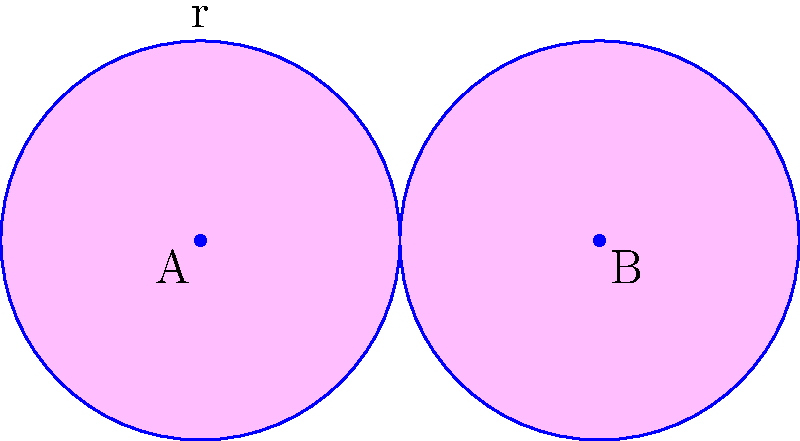In the diagram above, two circles with radius $r=1$ unit are centered at points A and B, which are 2 units apart. The overlapping region forms a heart shape, symbolic of the deep connection between two characters in a girls' love series. Calculate the area of this heart-shaped region. To find the area of the heart-shaped region, we'll follow these steps:

1) The total area of the heart shape is equal to the area of two circles minus the area of their intersection.

2) Area of one circle: $A_c = \pi r^2 = \pi (1)^2 = \pi$

3) Area of two circles: $2\pi$

4) To find the area of intersection, we need to calculate the area of the lens-shaped region formed by the overlapping circles.

5) The area of this lens can be calculated using the formula:
   $A_{\text{lens}} = 2r^2 \arccos(\frac{d}{2r}) - d\sqrt{r^2 - (\frac{d}{2})^2}$
   where $d$ is the distance between the centers and $r$ is the radius.

6) Here, $d = 2$ and $r = 1$, so:
   $A_{\text{lens}} = 2(1)^2 \arccos(\frac{2}{2(1)}) - 2\sqrt{1^2 - (\frac{2}{2})^2}$
   $= 2 \arccos(1) - 2\sqrt{1 - 1}$
   $= 2 \arccos(1) - 0 = 0$

7) Therefore, the area of the heart shape is:
   $A_{\text{heart}} = 2\pi - 0 = 2\pi$

Thus, the area of the heart-shaped region is $2\pi$ square units.
Answer: $2\pi$ square units 